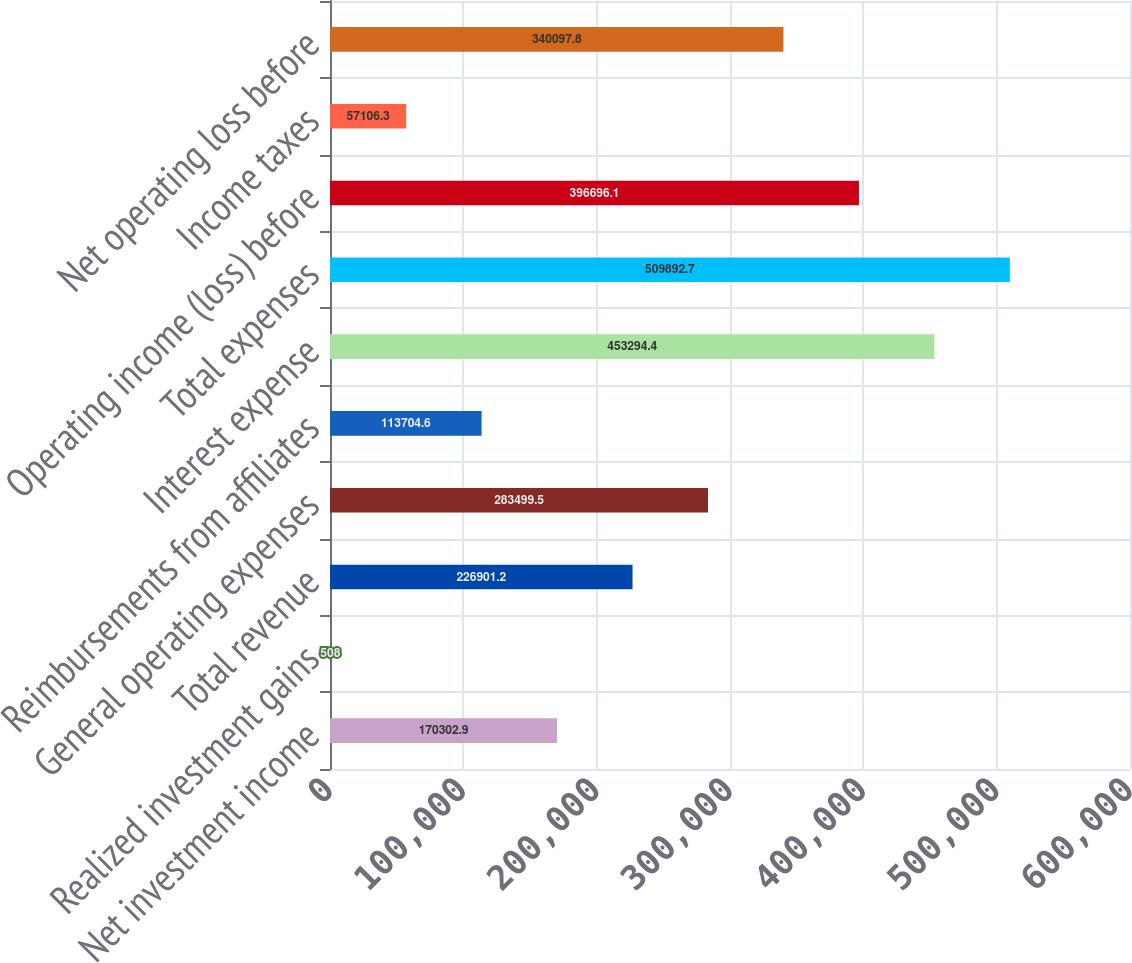Convert chart. <chart><loc_0><loc_0><loc_500><loc_500><bar_chart><fcel>Net investment income<fcel>Realized investment gains<fcel>Total revenue<fcel>General operating expenses<fcel>Reimbursements from affiliates<fcel>Interest expense<fcel>Total expenses<fcel>Operating income (loss) before<fcel>Income taxes<fcel>Net operating loss before<nl><fcel>170303<fcel>508<fcel>226901<fcel>283500<fcel>113705<fcel>453294<fcel>509893<fcel>396696<fcel>57106.3<fcel>340098<nl></chart> 